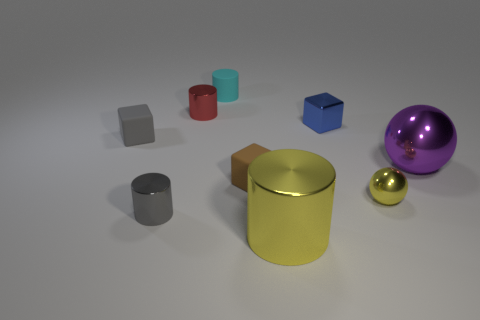Subtract all tiny rubber cubes. How many cubes are left? 1 Add 1 gray matte cylinders. How many objects exist? 10 Subtract all gray cylinders. How many cylinders are left? 3 Subtract all green cylinders. Subtract all purple blocks. How many cylinders are left? 4 Subtract all cubes. How many objects are left? 6 Add 6 purple shiny balls. How many purple shiny balls are left? 7 Add 8 tiny brown matte objects. How many tiny brown matte objects exist? 9 Subtract 0 red cubes. How many objects are left? 9 Subtract all tiny gray matte cylinders. Subtract all tiny brown matte cubes. How many objects are left? 8 